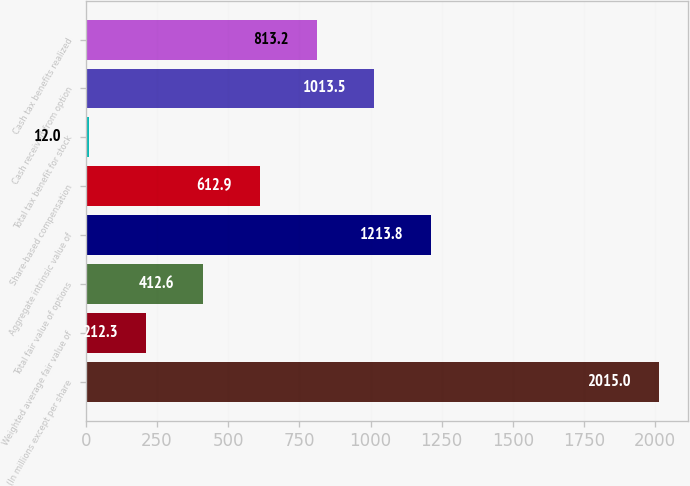<chart> <loc_0><loc_0><loc_500><loc_500><bar_chart><fcel>(In millions except per share<fcel>Weighted average fair value of<fcel>Total fair value of options<fcel>Aggregate intrinsic value of<fcel>Share-based compensation<fcel>Total tax benefit for stock<fcel>Cash received from option<fcel>Cash tax benefits realized<nl><fcel>2015<fcel>212.3<fcel>412.6<fcel>1213.8<fcel>612.9<fcel>12<fcel>1013.5<fcel>813.2<nl></chart> 